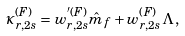<formula> <loc_0><loc_0><loc_500><loc_500>\kappa ^ { ( F ) } _ { r , 2 s } = w ^ { ^ { \prime } ( F ) } _ { r , 2 s } \hat { m } _ { f } + w ^ { ( F ) } _ { r , 2 s } \Lambda \, ,</formula> 